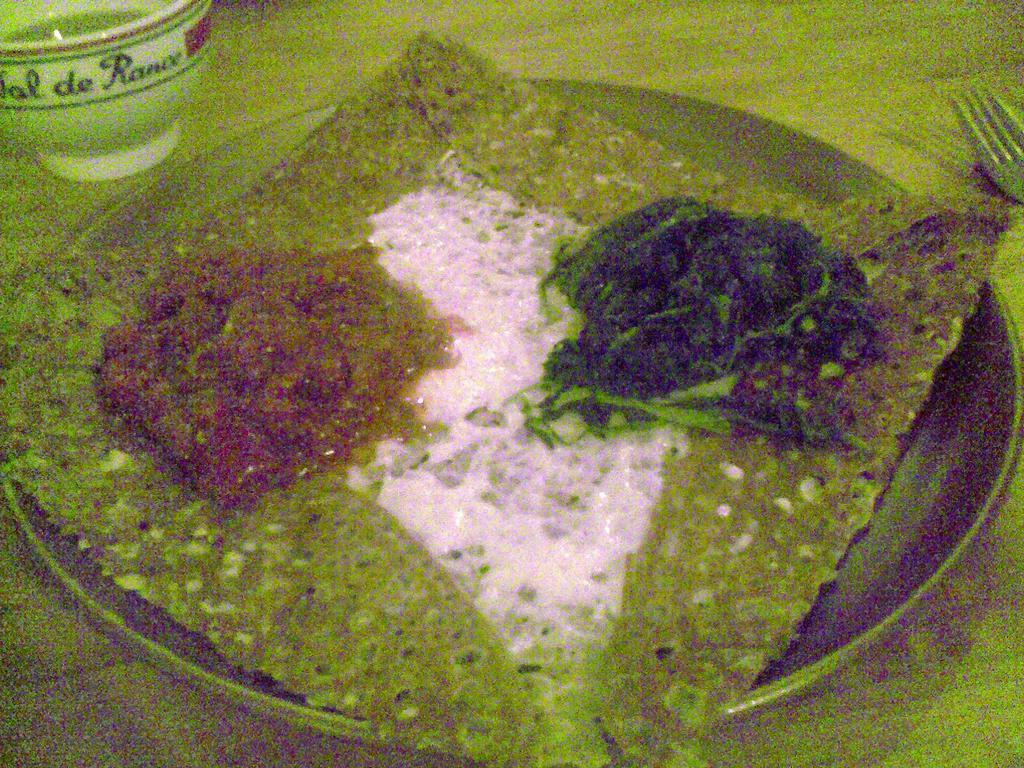What is the main object in the center of the image? There is a plate in the center of the image. What is on the plate? The plate contains food. What other dish is present beside the plate? There is a bowl beside the plate. What utensil is located beside the plate? A fork is present beside the plate. What piece of furniture is at the bottom of the image? There is a table at the bottom of the image. What type of education can be seen on the calculator in the image? There is no calculator present in the image, so it is not possible to determine what type of education might be displayed on it. 